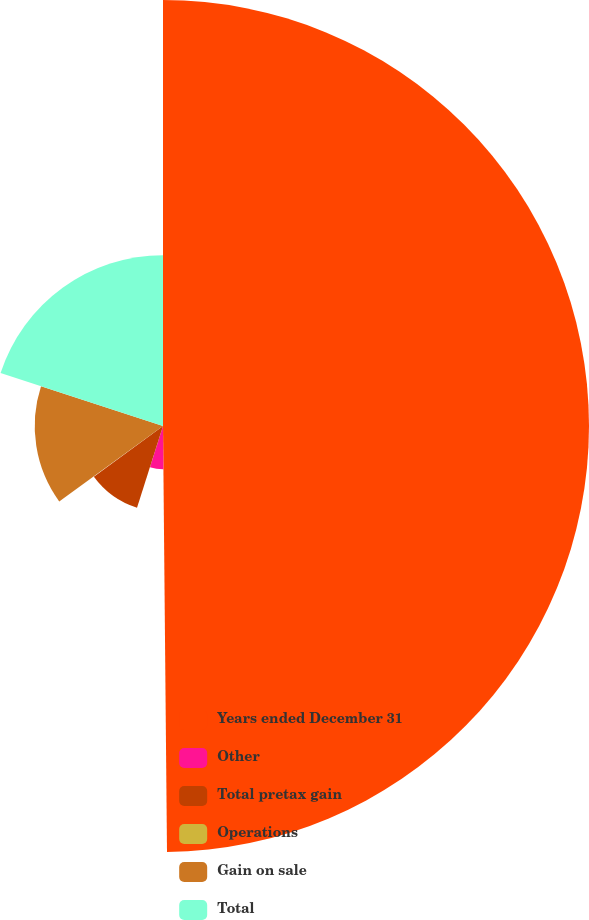Convert chart to OTSL. <chart><loc_0><loc_0><loc_500><loc_500><pie_chart><fcel>Years ended December 31<fcel>Other<fcel>Total pretax gain<fcel>Operations<fcel>Gain on sale<fcel>Total<nl><fcel>49.85%<fcel>5.05%<fcel>10.03%<fcel>0.07%<fcel>15.01%<fcel>19.99%<nl></chart> 